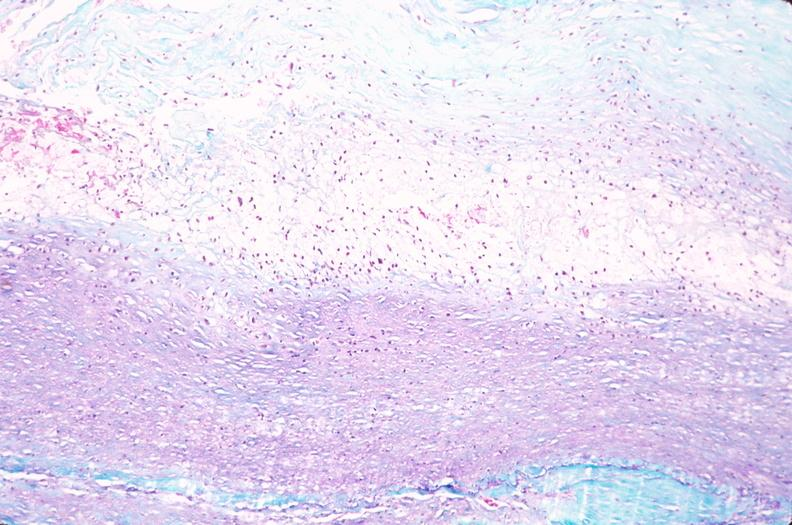s atherosclerosis present?
Answer the question using a single word or phrase. No 